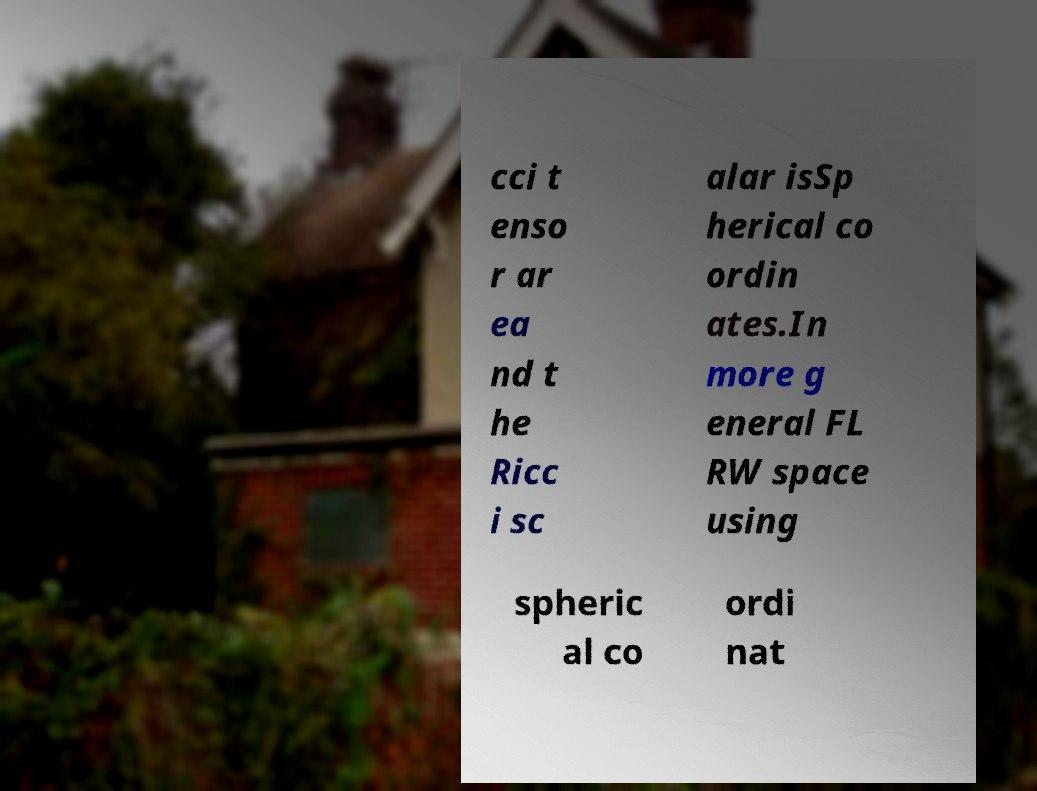Please identify and transcribe the text found in this image. cci t enso r ar ea nd t he Ricc i sc alar isSp herical co ordin ates.In more g eneral FL RW space using spheric al co ordi nat 